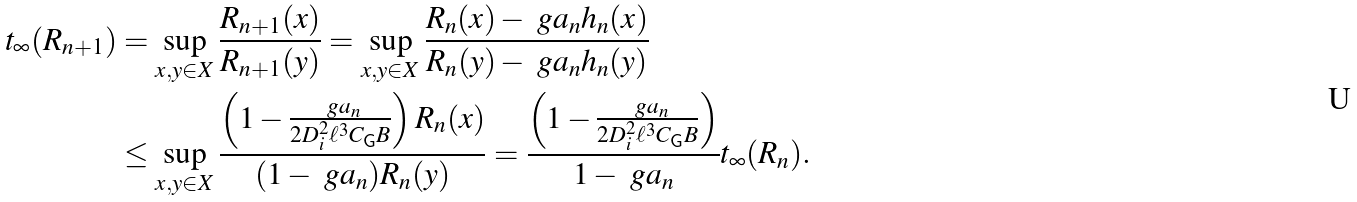<formula> <loc_0><loc_0><loc_500><loc_500>t _ { \infty } ( R _ { n + 1 } ) & = \sup _ { x , y \in X } \frac { R _ { n + 1 } ( x ) } { R _ { n + 1 } ( y ) } = \sup _ { x , y \in X } \frac { R _ { n } ( x ) - \ g a _ { n } h _ { n } ( x ) } { R _ { n } ( y ) - \ g a _ { n } h _ { n } ( y ) } \\ & \leq \sup _ { x , y \in X } \frac { \left ( 1 - \frac { \ g a _ { n } } { 2 D _ { i } ^ { 2 } \ell ^ { 3 } C _ { \mathsf G } B } \right ) R _ { n } ( x ) } { ( 1 - \ g a _ { n } ) R _ { n } ( y ) } = \frac { \left ( 1 - \frac { \ g a _ { n } } { 2 D _ { i } ^ { 2 } \ell ^ { 3 } C _ { \mathsf G } B } \right ) } { 1 - \ g a _ { n } } t _ { \infty } ( R _ { n } ) .</formula> 